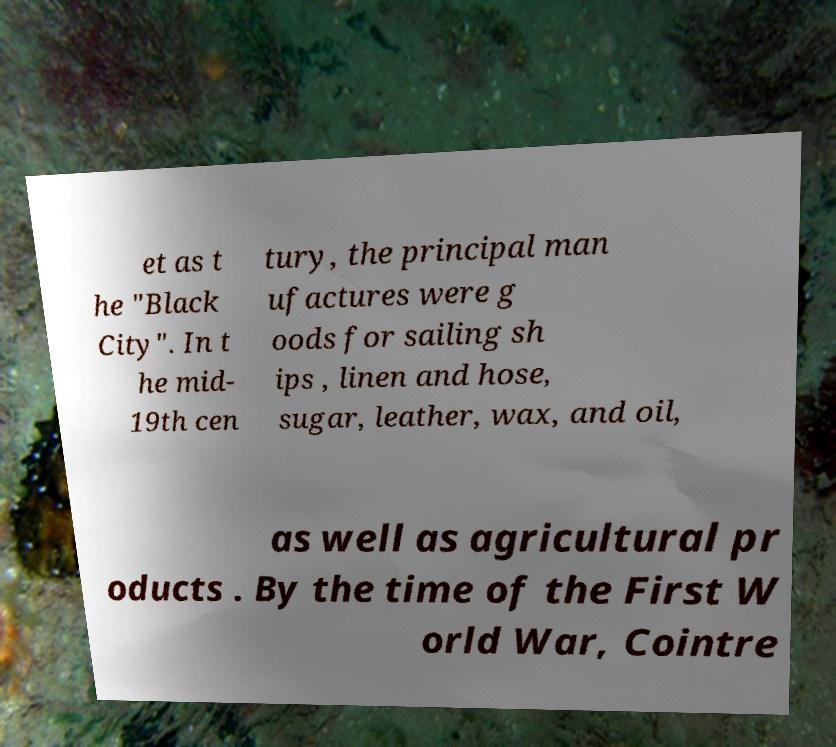Please read and relay the text visible in this image. What does it say? et as t he "Black City". In t he mid- 19th cen tury, the principal man ufactures were g oods for sailing sh ips , linen and hose, sugar, leather, wax, and oil, as well as agricultural pr oducts . By the time of the First W orld War, Cointre 